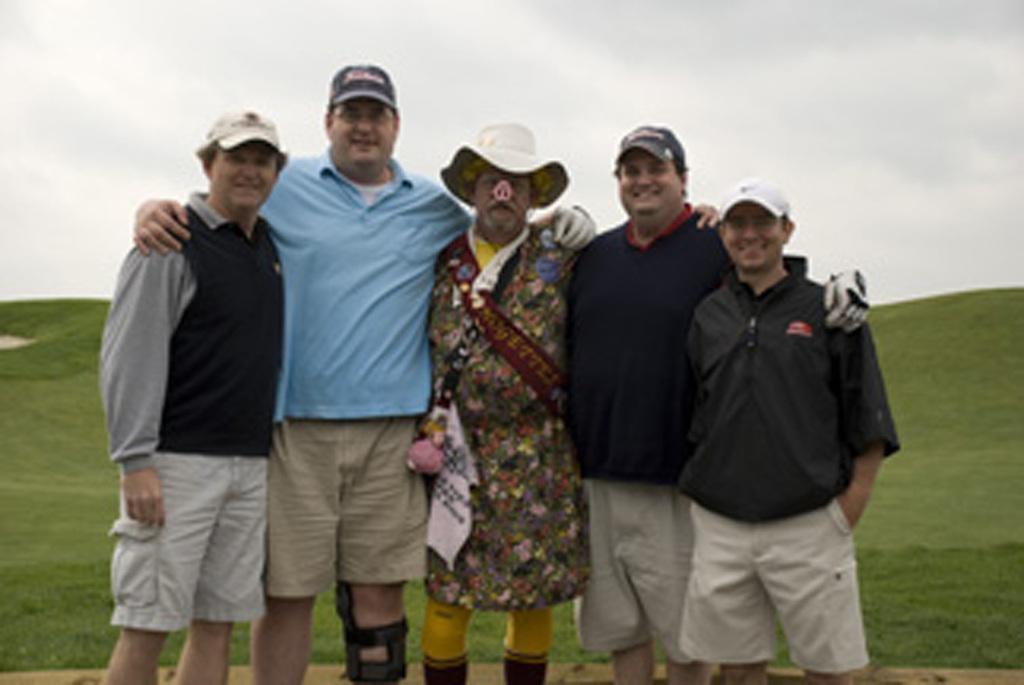In one or two sentences, can you explain what this image depicts? In this image there are a few people standing with a smile on their face, behind them there is grass. 